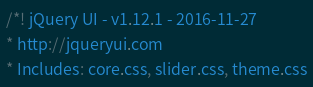<code> <loc_0><loc_0><loc_500><loc_500><_CSS_>/*! jQuery UI - v1.12.1 - 2016-11-27
* http://jqueryui.com
* Includes: core.css, slider.css, theme.css</code> 